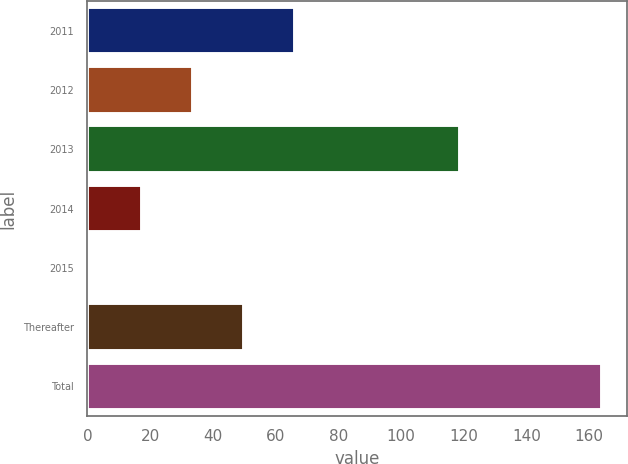Convert chart to OTSL. <chart><loc_0><loc_0><loc_500><loc_500><bar_chart><fcel>2011<fcel>2012<fcel>2013<fcel>2014<fcel>2015<fcel>Thereafter<fcel>Total<nl><fcel>66.2<fcel>33.6<fcel>119<fcel>17.3<fcel>1<fcel>49.9<fcel>164<nl></chart> 